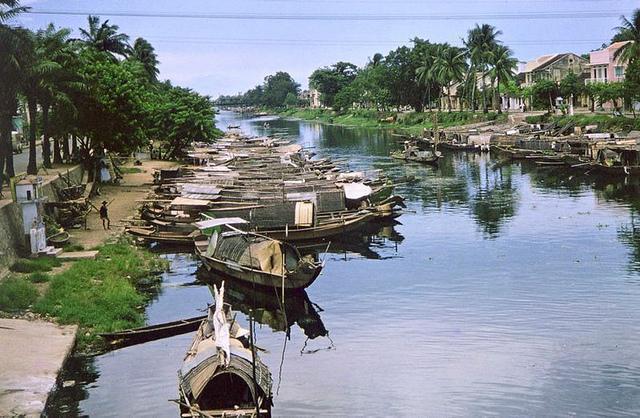What powers those boats?
Select the accurate response from the four choices given to answer the question.
Options: Humans, steam, gas, propane. Humans. 